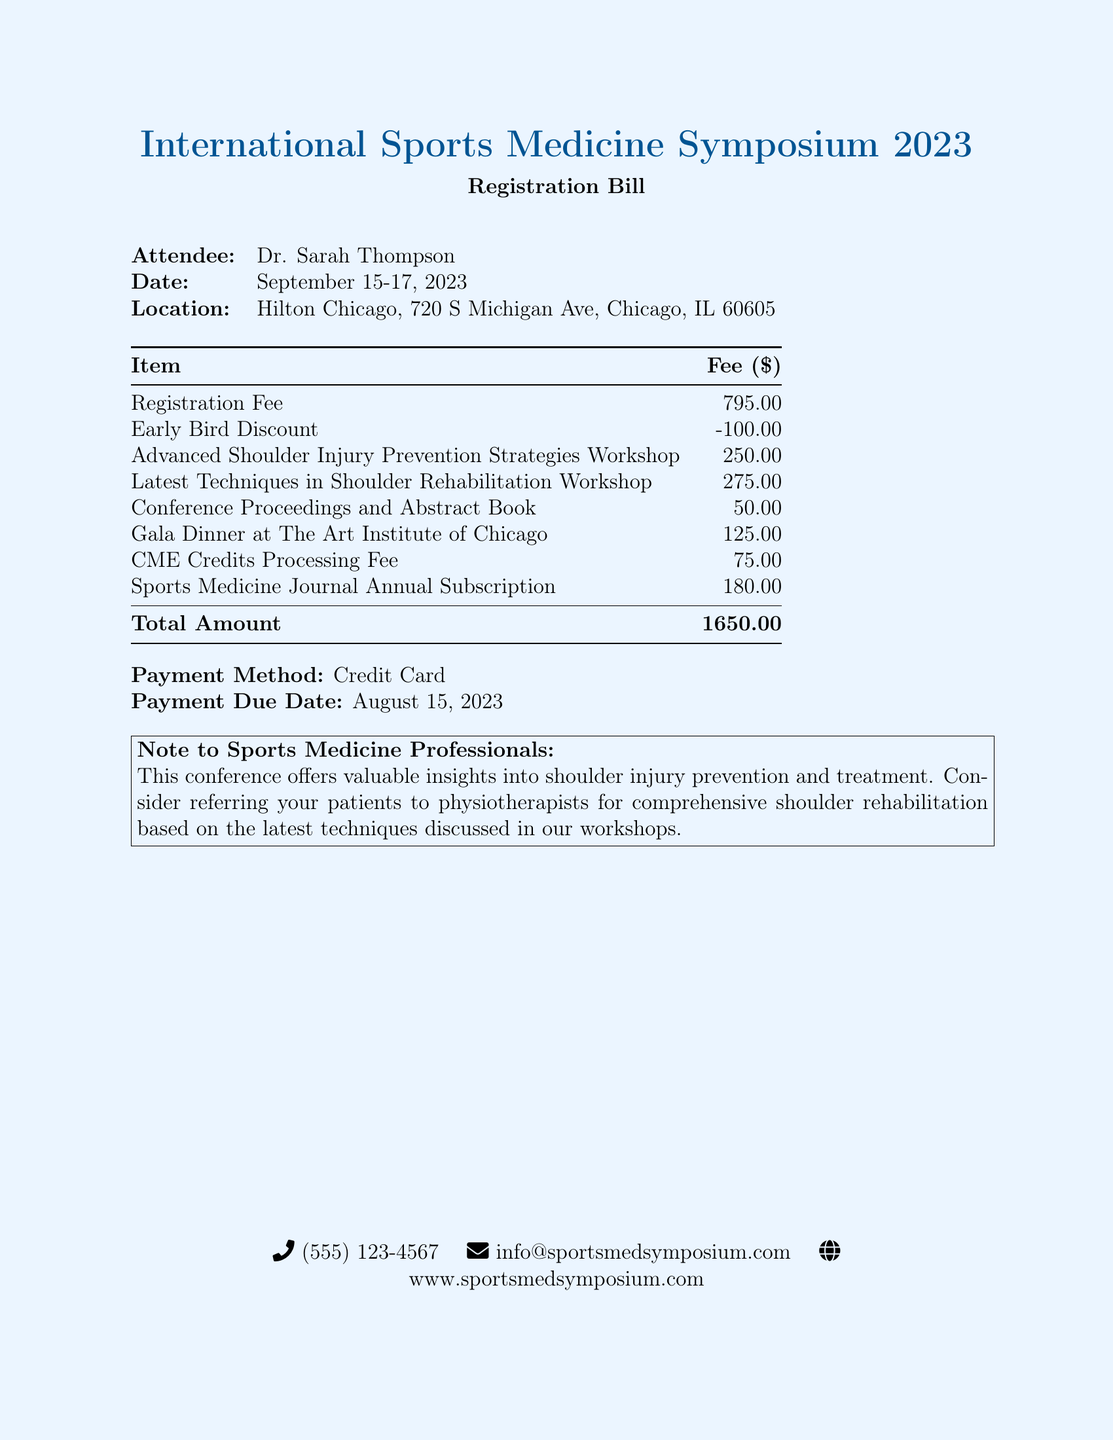What is the location of the symposium? The location is specified as Hilton Chicago, 720 S Michigan Ave, Chicago, IL 60605 in the document.
Answer: Hilton Chicago, 720 S Michigan Ave, Chicago, IL 60605 What is the registration fee? The registration fee is listed as 795.00 in the document.
Answer: 795.00 What is the date range of the conference? The date range is provided as September 15-17, 2023 in the document.
Answer: September 15-17, 2023 What discount was applied to the registration fee? The document shows an early bird discount of 100.00 applied to the registration fee.
Answer: 100.00 What is the total amount due? The total amount due is listed as 1650.00 in the document.
Answer: 1650.00 How much does the CME Credits Processing Fee cost? The document specifies the CME Credits Processing Fee as 75.00.
Answer: 75.00 What workshops are included in the registration? The document lists two workshops: Advanced Shoulder Injury Prevention Strategies Workshop and Latest Techniques in Shoulder Rehabilitation Workshop.
Answer: Advanced Shoulder Injury Prevention Strategies Workshop, Latest Techniques in Shoulder Rehabilitation Workshop What payment method is mentioned in the document? The payment method is indicated as Credit Card in the document.
Answer: Credit Card When is the payment due date? The payment due date is mentioned as August 15, 2023 in the document.
Answer: August 15, 2023 